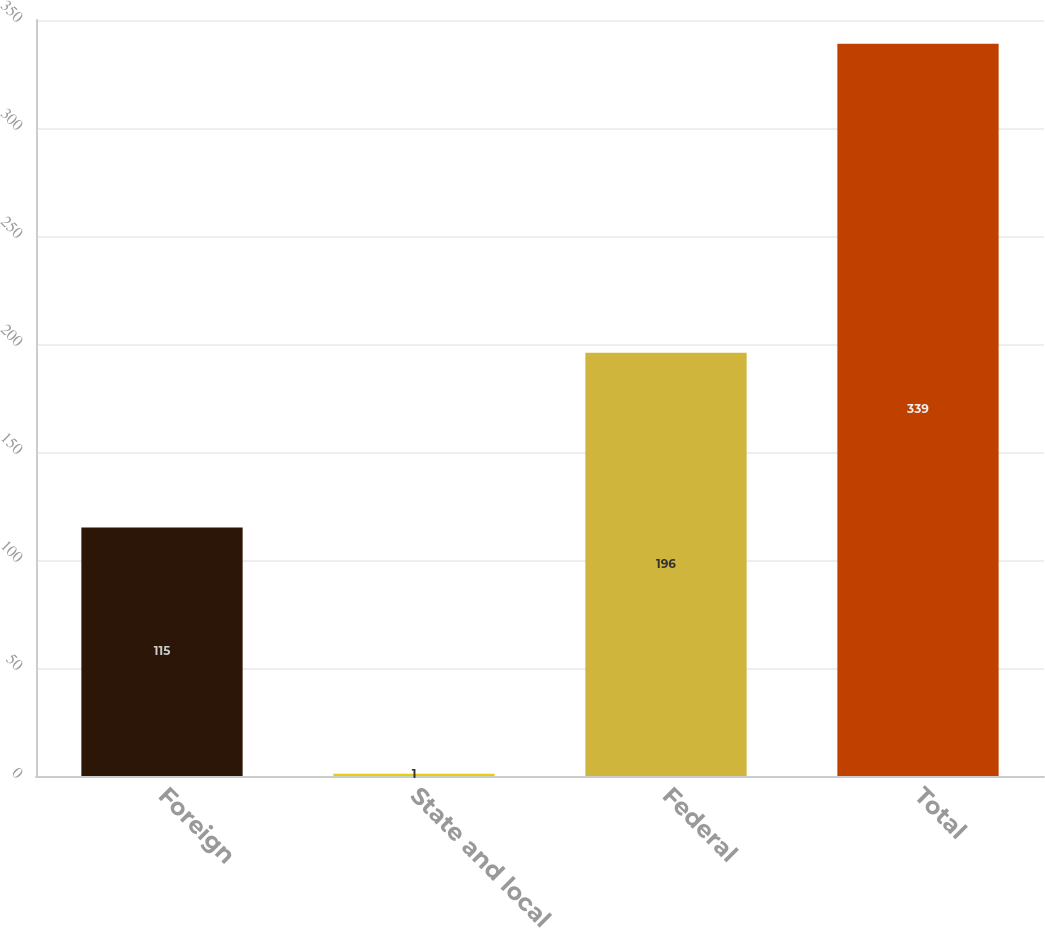Convert chart. <chart><loc_0><loc_0><loc_500><loc_500><bar_chart><fcel>Foreign<fcel>State and local<fcel>Federal<fcel>Total<nl><fcel>115<fcel>1<fcel>196<fcel>339<nl></chart> 